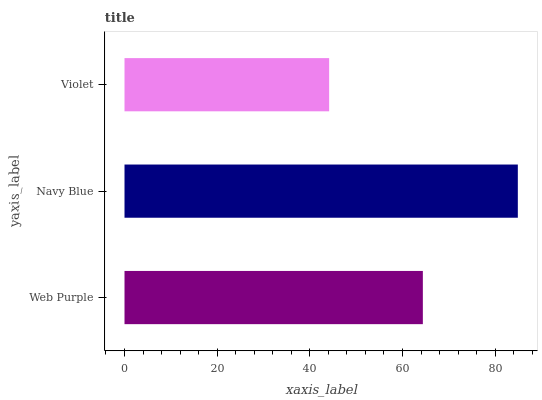Is Violet the minimum?
Answer yes or no. Yes. Is Navy Blue the maximum?
Answer yes or no. Yes. Is Navy Blue the minimum?
Answer yes or no. No. Is Violet the maximum?
Answer yes or no. No. Is Navy Blue greater than Violet?
Answer yes or no. Yes. Is Violet less than Navy Blue?
Answer yes or no. Yes. Is Violet greater than Navy Blue?
Answer yes or no. No. Is Navy Blue less than Violet?
Answer yes or no. No. Is Web Purple the high median?
Answer yes or no. Yes. Is Web Purple the low median?
Answer yes or no. Yes. Is Navy Blue the high median?
Answer yes or no. No. Is Navy Blue the low median?
Answer yes or no. No. 